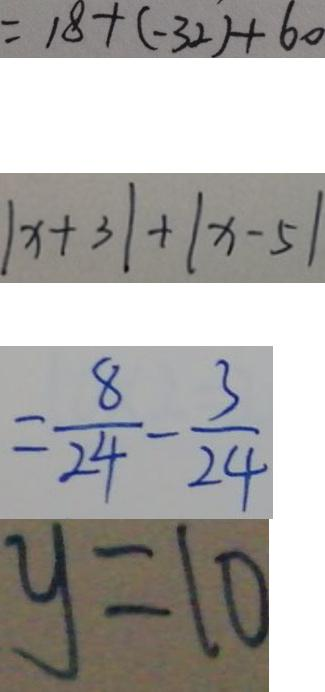Convert formula to latex. <formula><loc_0><loc_0><loc_500><loc_500>= 1 8 + ( - 3 2 ) + 6 0 
 \vert x + 3 \vert + \vert x - 5 \vert 
 = \frac { 8 } { 2 4 } - \frac { 3 } { 2 4 } 
 y = 1 0</formula> 